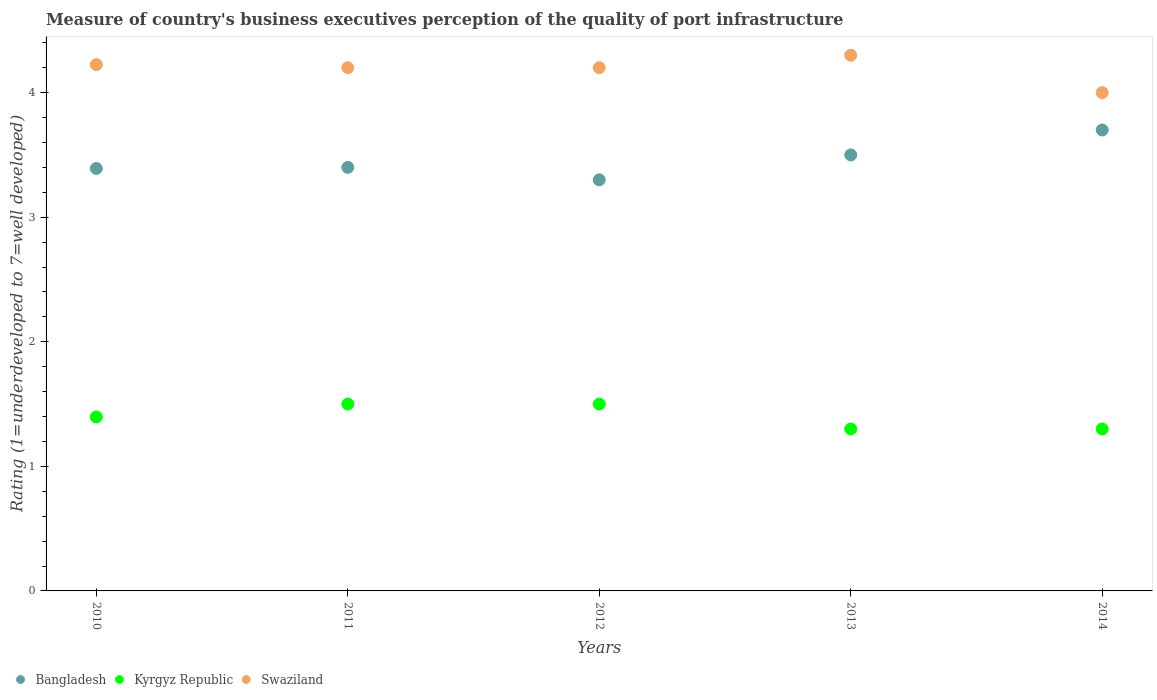What is the ratings of the quality of port infrastructure in Bangladesh in 2010?
Your answer should be compact. 3.39. Across all years, what is the minimum ratings of the quality of port infrastructure in Kyrgyz Republic?
Provide a short and direct response. 1.3. What is the total ratings of the quality of port infrastructure in Swaziland in the graph?
Your answer should be compact. 20.93. What is the difference between the ratings of the quality of port infrastructure in Bangladesh in 2010 and that in 2014?
Offer a very short reply. -0.31. What is the difference between the ratings of the quality of port infrastructure in Kyrgyz Republic in 2011 and the ratings of the quality of port infrastructure in Swaziland in 2013?
Keep it short and to the point. -2.8. What is the average ratings of the quality of port infrastructure in Bangladesh per year?
Your answer should be very brief. 3.46. In the year 2012, what is the difference between the ratings of the quality of port infrastructure in Bangladesh and ratings of the quality of port infrastructure in Kyrgyz Republic?
Ensure brevity in your answer.  1.8. What is the ratio of the ratings of the quality of port infrastructure in Swaziland in 2011 to that in 2013?
Provide a succinct answer. 0.98. What is the difference between the highest and the second highest ratings of the quality of port infrastructure in Bangladesh?
Your response must be concise. 0.2. What is the difference between the highest and the lowest ratings of the quality of port infrastructure in Swaziland?
Your answer should be compact. 0.3. In how many years, is the ratings of the quality of port infrastructure in Swaziland greater than the average ratings of the quality of port infrastructure in Swaziland taken over all years?
Ensure brevity in your answer.  4. Is the sum of the ratings of the quality of port infrastructure in Swaziland in 2010 and 2011 greater than the maximum ratings of the quality of port infrastructure in Kyrgyz Republic across all years?
Give a very brief answer. Yes. Is it the case that in every year, the sum of the ratings of the quality of port infrastructure in Bangladesh and ratings of the quality of port infrastructure in Kyrgyz Republic  is greater than the ratings of the quality of port infrastructure in Swaziland?
Give a very brief answer. Yes. Are the values on the major ticks of Y-axis written in scientific E-notation?
Make the answer very short. No. Does the graph contain grids?
Your response must be concise. No. What is the title of the graph?
Your answer should be very brief. Measure of country's business executives perception of the quality of port infrastructure. What is the label or title of the Y-axis?
Offer a very short reply. Rating (1=underdeveloped to 7=well developed). What is the Rating (1=underdeveloped to 7=well developed) in Bangladesh in 2010?
Offer a terse response. 3.39. What is the Rating (1=underdeveloped to 7=well developed) in Kyrgyz Republic in 2010?
Your answer should be compact. 1.4. What is the Rating (1=underdeveloped to 7=well developed) in Swaziland in 2010?
Keep it short and to the point. 4.23. What is the Rating (1=underdeveloped to 7=well developed) in Bangladesh in 2011?
Provide a short and direct response. 3.4. What is the Rating (1=underdeveloped to 7=well developed) in Kyrgyz Republic in 2011?
Provide a succinct answer. 1.5. What is the Rating (1=underdeveloped to 7=well developed) of Swaziland in 2011?
Make the answer very short. 4.2. What is the Rating (1=underdeveloped to 7=well developed) of Bangladesh in 2012?
Make the answer very short. 3.3. What is the Rating (1=underdeveloped to 7=well developed) of Kyrgyz Republic in 2012?
Give a very brief answer. 1.5. What is the Rating (1=underdeveloped to 7=well developed) in Swaziland in 2012?
Provide a succinct answer. 4.2. Across all years, what is the maximum Rating (1=underdeveloped to 7=well developed) in Kyrgyz Republic?
Your response must be concise. 1.5. Across all years, what is the minimum Rating (1=underdeveloped to 7=well developed) of Swaziland?
Your answer should be very brief. 4. What is the total Rating (1=underdeveloped to 7=well developed) in Bangladesh in the graph?
Offer a terse response. 17.29. What is the total Rating (1=underdeveloped to 7=well developed) of Kyrgyz Republic in the graph?
Offer a terse response. 7. What is the total Rating (1=underdeveloped to 7=well developed) of Swaziland in the graph?
Give a very brief answer. 20.93. What is the difference between the Rating (1=underdeveloped to 7=well developed) in Bangladesh in 2010 and that in 2011?
Offer a terse response. -0.01. What is the difference between the Rating (1=underdeveloped to 7=well developed) in Kyrgyz Republic in 2010 and that in 2011?
Your answer should be compact. -0.1. What is the difference between the Rating (1=underdeveloped to 7=well developed) of Swaziland in 2010 and that in 2011?
Provide a succinct answer. 0.03. What is the difference between the Rating (1=underdeveloped to 7=well developed) in Bangladesh in 2010 and that in 2012?
Your response must be concise. 0.09. What is the difference between the Rating (1=underdeveloped to 7=well developed) in Kyrgyz Republic in 2010 and that in 2012?
Offer a terse response. -0.1. What is the difference between the Rating (1=underdeveloped to 7=well developed) in Swaziland in 2010 and that in 2012?
Provide a succinct answer. 0.03. What is the difference between the Rating (1=underdeveloped to 7=well developed) in Bangladesh in 2010 and that in 2013?
Provide a short and direct response. -0.11. What is the difference between the Rating (1=underdeveloped to 7=well developed) of Kyrgyz Republic in 2010 and that in 2013?
Keep it short and to the point. 0.1. What is the difference between the Rating (1=underdeveloped to 7=well developed) in Swaziland in 2010 and that in 2013?
Your response must be concise. -0.07. What is the difference between the Rating (1=underdeveloped to 7=well developed) in Bangladesh in 2010 and that in 2014?
Your answer should be very brief. -0.31. What is the difference between the Rating (1=underdeveloped to 7=well developed) in Kyrgyz Republic in 2010 and that in 2014?
Ensure brevity in your answer.  0.1. What is the difference between the Rating (1=underdeveloped to 7=well developed) of Swaziland in 2010 and that in 2014?
Offer a terse response. 0.23. What is the difference between the Rating (1=underdeveloped to 7=well developed) of Bangladesh in 2011 and that in 2012?
Give a very brief answer. 0.1. What is the difference between the Rating (1=underdeveloped to 7=well developed) in Kyrgyz Republic in 2011 and that in 2012?
Keep it short and to the point. 0. What is the difference between the Rating (1=underdeveloped to 7=well developed) of Bangladesh in 2011 and that in 2013?
Make the answer very short. -0.1. What is the difference between the Rating (1=underdeveloped to 7=well developed) of Bangladesh in 2011 and that in 2014?
Offer a very short reply. -0.3. What is the difference between the Rating (1=underdeveloped to 7=well developed) of Kyrgyz Republic in 2012 and that in 2013?
Provide a short and direct response. 0.2. What is the difference between the Rating (1=underdeveloped to 7=well developed) in Bangladesh in 2012 and that in 2014?
Offer a very short reply. -0.4. What is the difference between the Rating (1=underdeveloped to 7=well developed) of Kyrgyz Republic in 2012 and that in 2014?
Give a very brief answer. 0.2. What is the difference between the Rating (1=underdeveloped to 7=well developed) in Bangladesh in 2010 and the Rating (1=underdeveloped to 7=well developed) in Kyrgyz Republic in 2011?
Ensure brevity in your answer.  1.89. What is the difference between the Rating (1=underdeveloped to 7=well developed) in Bangladesh in 2010 and the Rating (1=underdeveloped to 7=well developed) in Swaziland in 2011?
Offer a very short reply. -0.81. What is the difference between the Rating (1=underdeveloped to 7=well developed) in Kyrgyz Republic in 2010 and the Rating (1=underdeveloped to 7=well developed) in Swaziland in 2011?
Provide a succinct answer. -2.8. What is the difference between the Rating (1=underdeveloped to 7=well developed) of Bangladesh in 2010 and the Rating (1=underdeveloped to 7=well developed) of Kyrgyz Republic in 2012?
Give a very brief answer. 1.89. What is the difference between the Rating (1=underdeveloped to 7=well developed) in Bangladesh in 2010 and the Rating (1=underdeveloped to 7=well developed) in Swaziland in 2012?
Your response must be concise. -0.81. What is the difference between the Rating (1=underdeveloped to 7=well developed) of Kyrgyz Republic in 2010 and the Rating (1=underdeveloped to 7=well developed) of Swaziland in 2012?
Your answer should be compact. -2.8. What is the difference between the Rating (1=underdeveloped to 7=well developed) of Bangladesh in 2010 and the Rating (1=underdeveloped to 7=well developed) of Kyrgyz Republic in 2013?
Ensure brevity in your answer.  2.09. What is the difference between the Rating (1=underdeveloped to 7=well developed) in Bangladesh in 2010 and the Rating (1=underdeveloped to 7=well developed) in Swaziland in 2013?
Give a very brief answer. -0.91. What is the difference between the Rating (1=underdeveloped to 7=well developed) of Kyrgyz Republic in 2010 and the Rating (1=underdeveloped to 7=well developed) of Swaziland in 2013?
Your answer should be very brief. -2.9. What is the difference between the Rating (1=underdeveloped to 7=well developed) in Bangladesh in 2010 and the Rating (1=underdeveloped to 7=well developed) in Kyrgyz Republic in 2014?
Offer a terse response. 2.09. What is the difference between the Rating (1=underdeveloped to 7=well developed) of Bangladesh in 2010 and the Rating (1=underdeveloped to 7=well developed) of Swaziland in 2014?
Offer a terse response. -0.61. What is the difference between the Rating (1=underdeveloped to 7=well developed) in Kyrgyz Republic in 2010 and the Rating (1=underdeveloped to 7=well developed) in Swaziland in 2014?
Provide a short and direct response. -2.6. What is the difference between the Rating (1=underdeveloped to 7=well developed) in Kyrgyz Republic in 2011 and the Rating (1=underdeveloped to 7=well developed) in Swaziland in 2012?
Your response must be concise. -2.7. What is the difference between the Rating (1=underdeveloped to 7=well developed) in Bangladesh in 2011 and the Rating (1=underdeveloped to 7=well developed) in Kyrgyz Republic in 2013?
Provide a short and direct response. 2.1. What is the difference between the Rating (1=underdeveloped to 7=well developed) of Bangladesh in 2011 and the Rating (1=underdeveloped to 7=well developed) of Swaziland in 2013?
Your answer should be compact. -0.9. What is the difference between the Rating (1=underdeveloped to 7=well developed) of Kyrgyz Republic in 2011 and the Rating (1=underdeveloped to 7=well developed) of Swaziland in 2013?
Offer a terse response. -2.8. What is the difference between the Rating (1=underdeveloped to 7=well developed) in Bangladesh in 2012 and the Rating (1=underdeveloped to 7=well developed) in Kyrgyz Republic in 2013?
Provide a short and direct response. 2. What is the difference between the Rating (1=underdeveloped to 7=well developed) of Kyrgyz Republic in 2012 and the Rating (1=underdeveloped to 7=well developed) of Swaziland in 2013?
Your answer should be very brief. -2.8. What is the difference between the Rating (1=underdeveloped to 7=well developed) in Bangladesh in 2012 and the Rating (1=underdeveloped to 7=well developed) in Swaziland in 2014?
Provide a succinct answer. -0.7. What is the difference between the Rating (1=underdeveloped to 7=well developed) in Kyrgyz Republic in 2012 and the Rating (1=underdeveloped to 7=well developed) in Swaziland in 2014?
Keep it short and to the point. -2.5. What is the difference between the Rating (1=underdeveloped to 7=well developed) of Bangladesh in 2013 and the Rating (1=underdeveloped to 7=well developed) of Kyrgyz Republic in 2014?
Give a very brief answer. 2.2. What is the difference between the Rating (1=underdeveloped to 7=well developed) of Bangladesh in 2013 and the Rating (1=underdeveloped to 7=well developed) of Swaziland in 2014?
Ensure brevity in your answer.  -0.5. What is the average Rating (1=underdeveloped to 7=well developed) of Bangladesh per year?
Give a very brief answer. 3.46. What is the average Rating (1=underdeveloped to 7=well developed) in Kyrgyz Republic per year?
Give a very brief answer. 1.4. What is the average Rating (1=underdeveloped to 7=well developed) in Swaziland per year?
Your answer should be very brief. 4.18. In the year 2010, what is the difference between the Rating (1=underdeveloped to 7=well developed) of Bangladesh and Rating (1=underdeveloped to 7=well developed) of Kyrgyz Republic?
Offer a terse response. 1.99. In the year 2010, what is the difference between the Rating (1=underdeveloped to 7=well developed) in Bangladesh and Rating (1=underdeveloped to 7=well developed) in Swaziland?
Offer a terse response. -0.83. In the year 2010, what is the difference between the Rating (1=underdeveloped to 7=well developed) in Kyrgyz Republic and Rating (1=underdeveloped to 7=well developed) in Swaziland?
Keep it short and to the point. -2.83. In the year 2011, what is the difference between the Rating (1=underdeveloped to 7=well developed) in Bangladesh and Rating (1=underdeveloped to 7=well developed) in Kyrgyz Republic?
Keep it short and to the point. 1.9. In the year 2012, what is the difference between the Rating (1=underdeveloped to 7=well developed) in Kyrgyz Republic and Rating (1=underdeveloped to 7=well developed) in Swaziland?
Ensure brevity in your answer.  -2.7. In the year 2013, what is the difference between the Rating (1=underdeveloped to 7=well developed) in Kyrgyz Republic and Rating (1=underdeveloped to 7=well developed) in Swaziland?
Offer a terse response. -3. In the year 2014, what is the difference between the Rating (1=underdeveloped to 7=well developed) of Bangladesh and Rating (1=underdeveloped to 7=well developed) of Swaziland?
Offer a very short reply. -0.3. What is the ratio of the Rating (1=underdeveloped to 7=well developed) of Bangladesh in 2010 to that in 2012?
Offer a terse response. 1.03. What is the ratio of the Rating (1=underdeveloped to 7=well developed) of Kyrgyz Republic in 2010 to that in 2012?
Your answer should be very brief. 0.93. What is the ratio of the Rating (1=underdeveloped to 7=well developed) of Swaziland in 2010 to that in 2012?
Offer a terse response. 1.01. What is the ratio of the Rating (1=underdeveloped to 7=well developed) in Bangladesh in 2010 to that in 2013?
Your answer should be compact. 0.97. What is the ratio of the Rating (1=underdeveloped to 7=well developed) of Kyrgyz Republic in 2010 to that in 2013?
Offer a very short reply. 1.07. What is the ratio of the Rating (1=underdeveloped to 7=well developed) in Swaziland in 2010 to that in 2013?
Keep it short and to the point. 0.98. What is the ratio of the Rating (1=underdeveloped to 7=well developed) of Bangladesh in 2010 to that in 2014?
Provide a short and direct response. 0.92. What is the ratio of the Rating (1=underdeveloped to 7=well developed) of Kyrgyz Republic in 2010 to that in 2014?
Provide a short and direct response. 1.07. What is the ratio of the Rating (1=underdeveloped to 7=well developed) in Swaziland in 2010 to that in 2014?
Keep it short and to the point. 1.06. What is the ratio of the Rating (1=underdeveloped to 7=well developed) in Bangladesh in 2011 to that in 2012?
Offer a very short reply. 1.03. What is the ratio of the Rating (1=underdeveloped to 7=well developed) in Kyrgyz Republic in 2011 to that in 2012?
Provide a succinct answer. 1. What is the ratio of the Rating (1=underdeveloped to 7=well developed) of Swaziland in 2011 to that in 2012?
Provide a succinct answer. 1. What is the ratio of the Rating (1=underdeveloped to 7=well developed) of Bangladesh in 2011 to that in 2013?
Your response must be concise. 0.97. What is the ratio of the Rating (1=underdeveloped to 7=well developed) of Kyrgyz Republic in 2011 to that in 2013?
Your answer should be compact. 1.15. What is the ratio of the Rating (1=underdeveloped to 7=well developed) in Swaziland in 2011 to that in 2013?
Provide a succinct answer. 0.98. What is the ratio of the Rating (1=underdeveloped to 7=well developed) of Bangladesh in 2011 to that in 2014?
Your answer should be compact. 0.92. What is the ratio of the Rating (1=underdeveloped to 7=well developed) in Kyrgyz Republic in 2011 to that in 2014?
Your answer should be very brief. 1.15. What is the ratio of the Rating (1=underdeveloped to 7=well developed) of Bangladesh in 2012 to that in 2013?
Offer a terse response. 0.94. What is the ratio of the Rating (1=underdeveloped to 7=well developed) of Kyrgyz Republic in 2012 to that in 2013?
Give a very brief answer. 1.15. What is the ratio of the Rating (1=underdeveloped to 7=well developed) in Swaziland in 2012 to that in 2013?
Provide a short and direct response. 0.98. What is the ratio of the Rating (1=underdeveloped to 7=well developed) of Bangladesh in 2012 to that in 2014?
Give a very brief answer. 0.89. What is the ratio of the Rating (1=underdeveloped to 7=well developed) of Kyrgyz Republic in 2012 to that in 2014?
Ensure brevity in your answer.  1.15. What is the ratio of the Rating (1=underdeveloped to 7=well developed) of Swaziland in 2012 to that in 2014?
Offer a very short reply. 1.05. What is the ratio of the Rating (1=underdeveloped to 7=well developed) of Bangladesh in 2013 to that in 2014?
Your answer should be compact. 0.95. What is the ratio of the Rating (1=underdeveloped to 7=well developed) of Swaziland in 2013 to that in 2014?
Keep it short and to the point. 1.07. What is the difference between the highest and the second highest Rating (1=underdeveloped to 7=well developed) in Kyrgyz Republic?
Provide a succinct answer. 0. What is the difference between the highest and the second highest Rating (1=underdeveloped to 7=well developed) of Swaziland?
Provide a succinct answer. 0.07. What is the difference between the highest and the lowest Rating (1=underdeveloped to 7=well developed) of Bangladesh?
Provide a short and direct response. 0.4. What is the difference between the highest and the lowest Rating (1=underdeveloped to 7=well developed) of Kyrgyz Republic?
Provide a short and direct response. 0.2. 